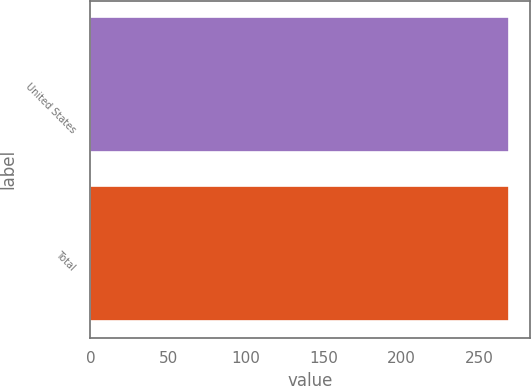<chart> <loc_0><loc_0><loc_500><loc_500><bar_chart><fcel>United States<fcel>Total<nl><fcel>269<fcel>269.1<nl></chart> 